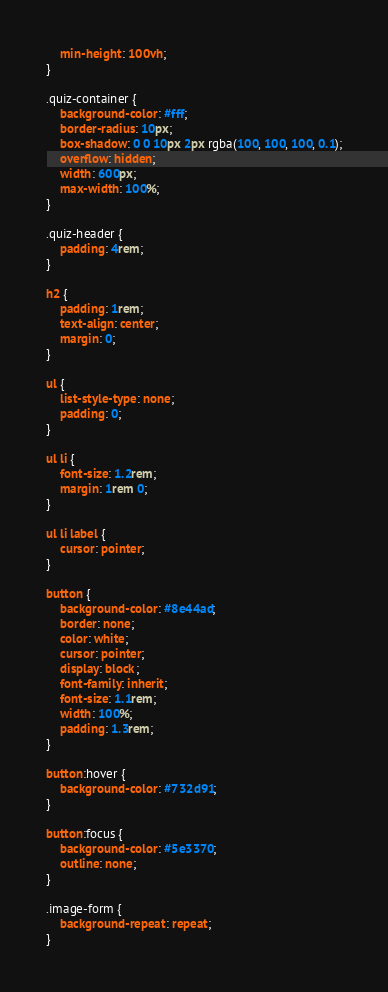<code> <loc_0><loc_0><loc_500><loc_500><_CSS_>    min-height: 100vh;
}

.quiz-container {
    background-color: #fff;
    border-radius: 10px;
    box-shadow: 0 0 10px 2px rgba(100, 100, 100, 0.1);
    overflow: hidden;
    width: 600px;
    max-width: 100%;
}

.quiz-header {
    padding: 4rem;
}

h2 {
    padding: 1rem;
    text-align: center;
    margin: 0;
}

ul {
    list-style-type: none;
    padding: 0;
}

ul li {
    font-size: 1.2rem;
    margin: 1rem 0;
}

ul li label {
    cursor: pointer;
}

button {
    background-color: #8e44ad;
    border: none;
    color: white;
    cursor: pointer;
    display: block;
    font-family: inherit;
    font-size: 1.1rem;
    width: 100%;
    padding: 1.3rem;
}

button:hover {
    background-color: #732d91;
}

button:focus {
    background-color: #5e3370;
    outline: none;
}

.image-form {
    background-repeat: repeat;
}</code> 